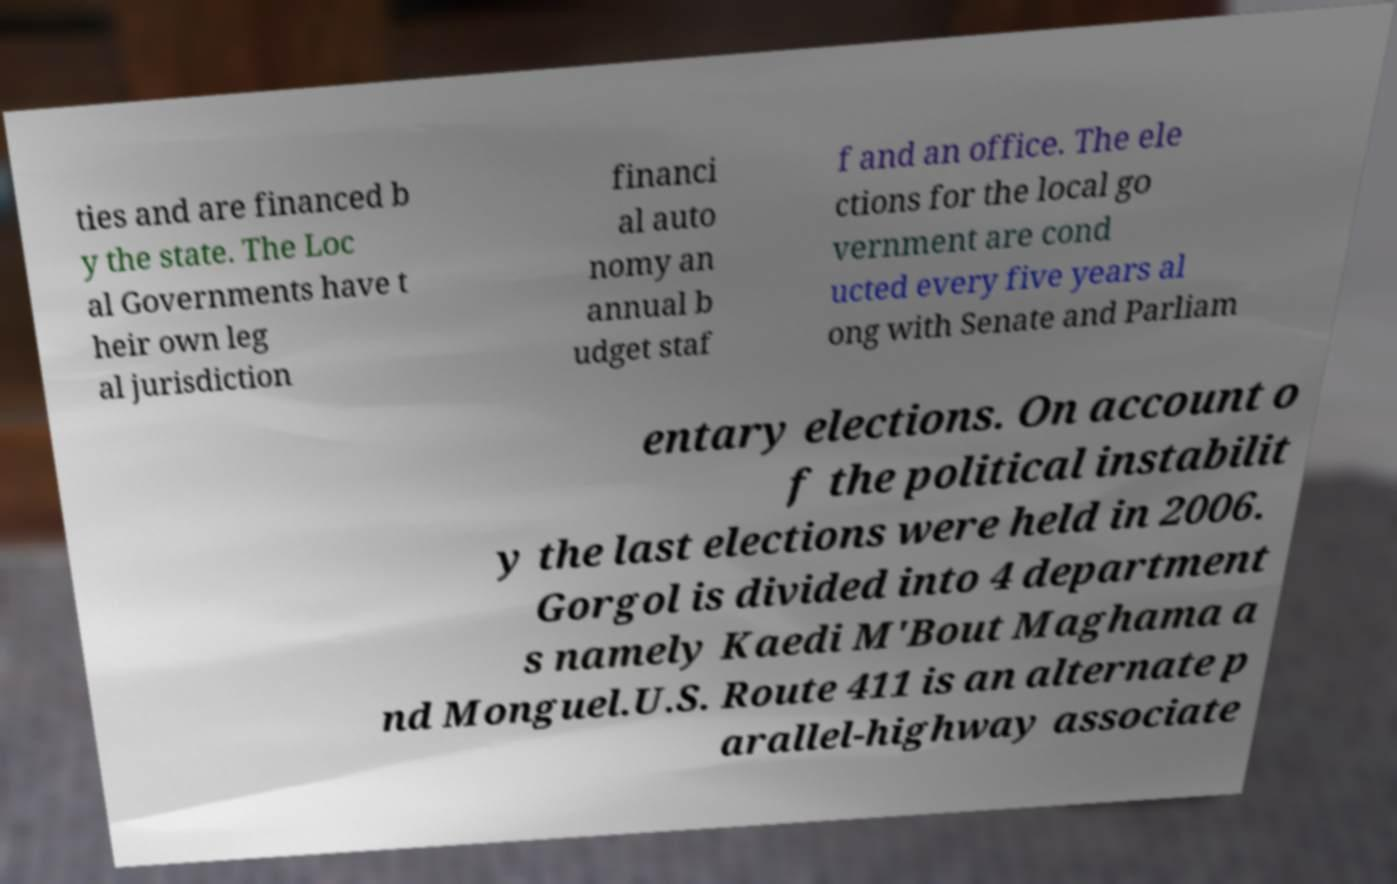For documentation purposes, I need the text within this image transcribed. Could you provide that? ties and are financed b y the state. The Loc al Governments have t heir own leg al jurisdiction financi al auto nomy an annual b udget staf f and an office. The ele ctions for the local go vernment are cond ucted every five years al ong with Senate and Parliam entary elections. On account o f the political instabilit y the last elections were held in 2006. Gorgol is divided into 4 department s namely Kaedi M'Bout Maghama a nd Monguel.U.S. Route 411 is an alternate p arallel-highway associate 